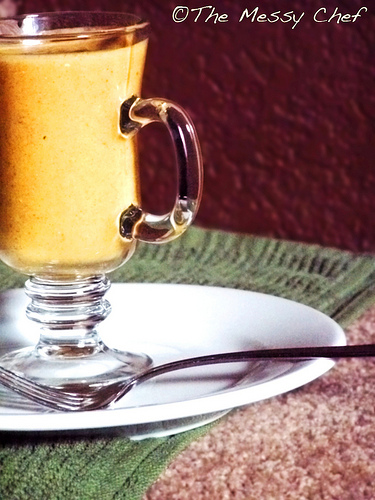<image>
Can you confirm if the fork is in the glass? No. The fork is not contained within the glass. These objects have a different spatial relationship. Is the fork on the table? No. The fork is not positioned on the table. They may be near each other, but the fork is not supported by or resting on top of the table. 